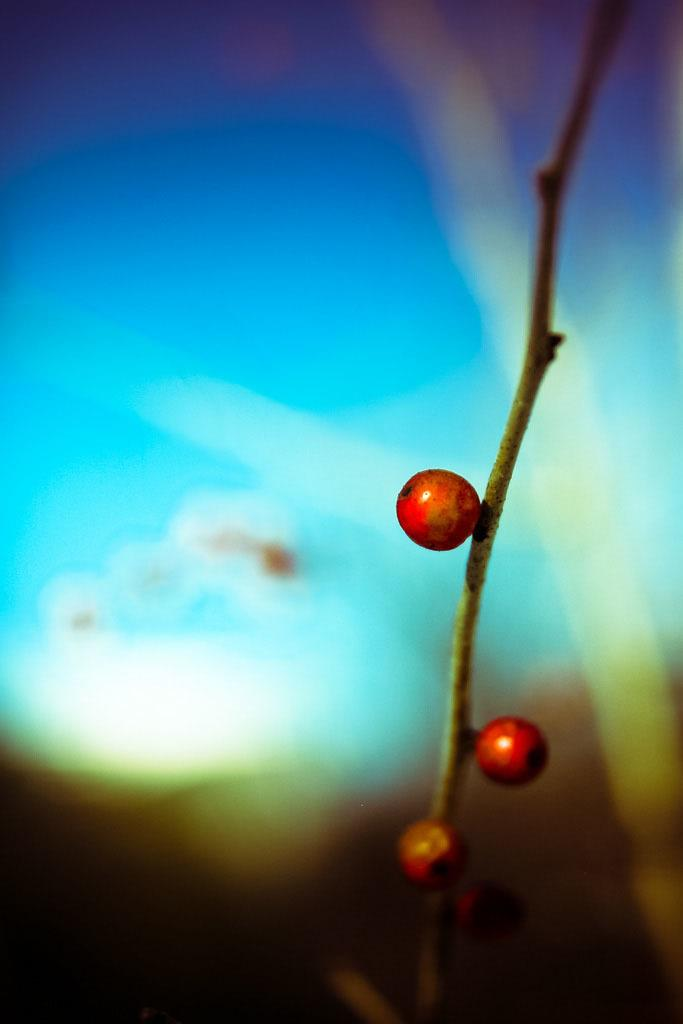What type of plant is visible in the image? There is a plant with fruits in the image. What can be seen in the distance behind the plant? There is a sky visible in the background of the image. Are there any other objects or features visible in the background? Yes, there are other objects in the background of the image. What riddle is the plant trying to solve in the image? There is no indication in the image that the plant is trying to solve a riddle. Can you tell me what type of camera was used to take the image? The type of camera used to take the image is not mentioned in the provided facts. 